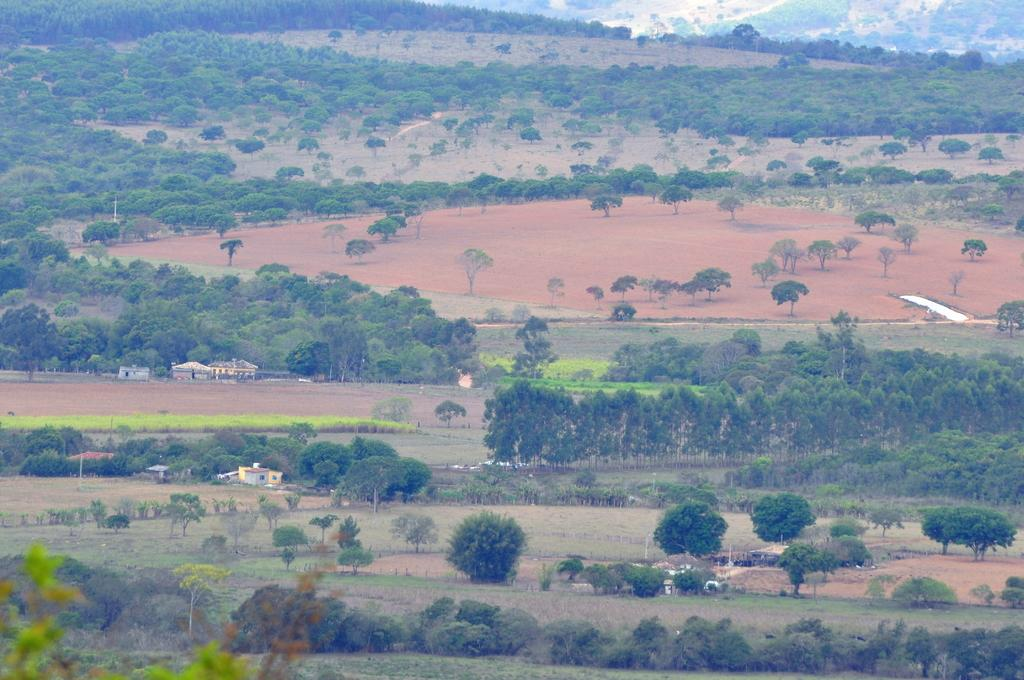What type of vegetation is present in the image? There are trees on the soil in the image. What type of structures can be seen in the image? There are houses in the image. What type of sack is hanging from the trees in the image? There is no sack present in the image; it only features trees and houses. What type of oatmeal can be seen being prepared in the image? There is no oatmeal or preparation of food visible in the image. 